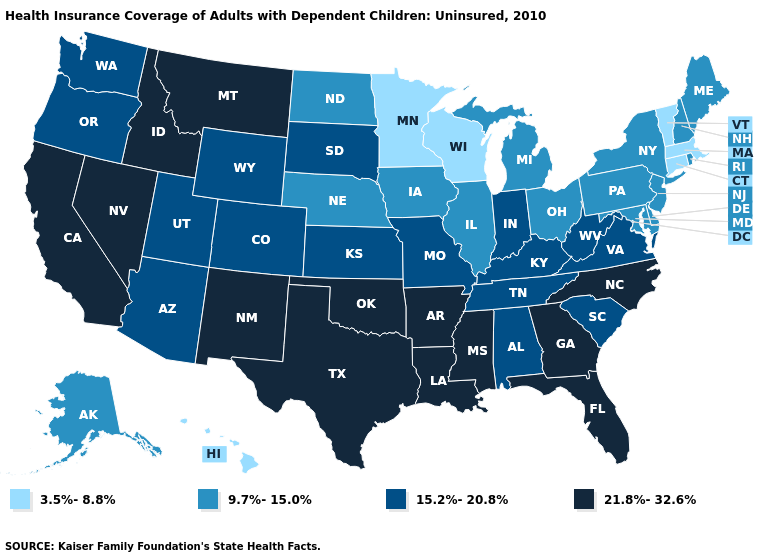What is the value of Nevada?
Quick response, please. 21.8%-32.6%. Which states have the highest value in the USA?
Concise answer only. Arkansas, California, Florida, Georgia, Idaho, Louisiana, Mississippi, Montana, Nevada, New Mexico, North Carolina, Oklahoma, Texas. Name the states that have a value in the range 15.2%-20.8%?
Give a very brief answer. Alabama, Arizona, Colorado, Indiana, Kansas, Kentucky, Missouri, Oregon, South Carolina, South Dakota, Tennessee, Utah, Virginia, Washington, West Virginia, Wyoming. What is the value of Virginia?
Short answer required. 15.2%-20.8%. What is the value of Alaska?
Write a very short answer. 9.7%-15.0%. What is the highest value in the USA?
Write a very short answer. 21.8%-32.6%. What is the value of Virginia?
Keep it brief. 15.2%-20.8%. Name the states that have a value in the range 15.2%-20.8%?
Concise answer only. Alabama, Arizona, Colorado, Indiana, Kansas, Kentucky, Missouri, Oregon, South Carolina, South Dakota, Tennessee, Utah, Virginia, Washington, West Virginia, Wyoming. Among the states that border Tennessee , does Mississippi have the lowest value?
Short answer required. No. What is the value of California?
Give a very brief answer. 21.8%-32.6%. Among the states that border West Virginia , does Maryland have the lowest value?
Keep it brief. Yes. What is the value of Louisiana?
Write a very short answer. 21.8%-32.6%. What is the value of Kansas?
Answer briefly. 15.2%-20.8%. Does Vermont have the lowest value in the USA?
Answer briefly. Yes. What is the lowest value in the West?
Quick response, please. 3.5%-8.8%. 